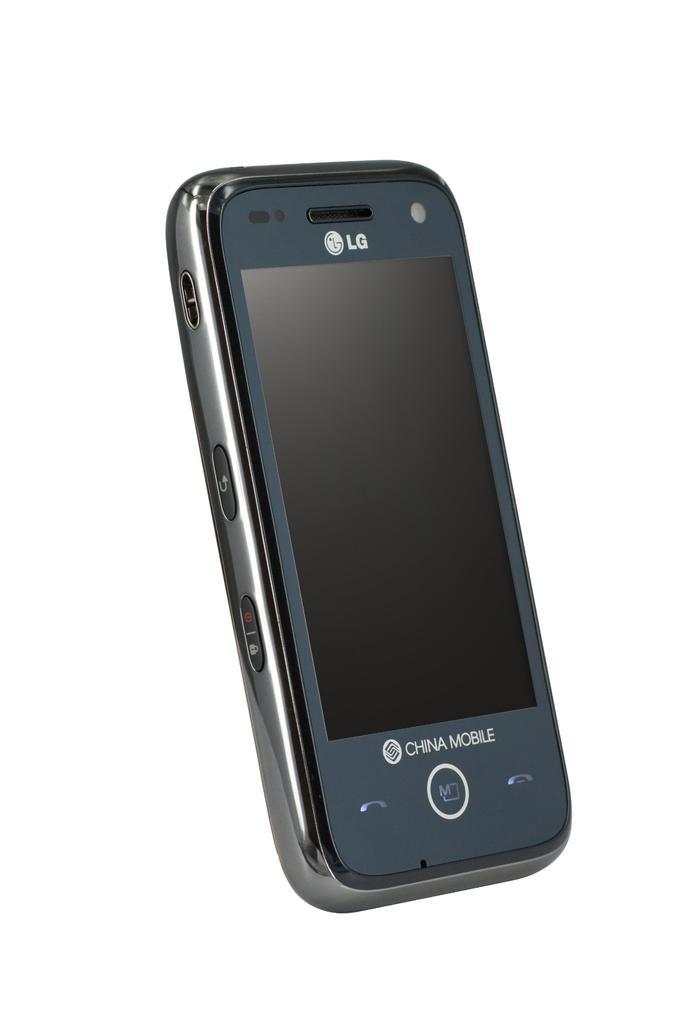What brand is the phone?
Provide a succinct answer. Lg. Is this phone from china mobile?
Your response must be concise. Yes. 